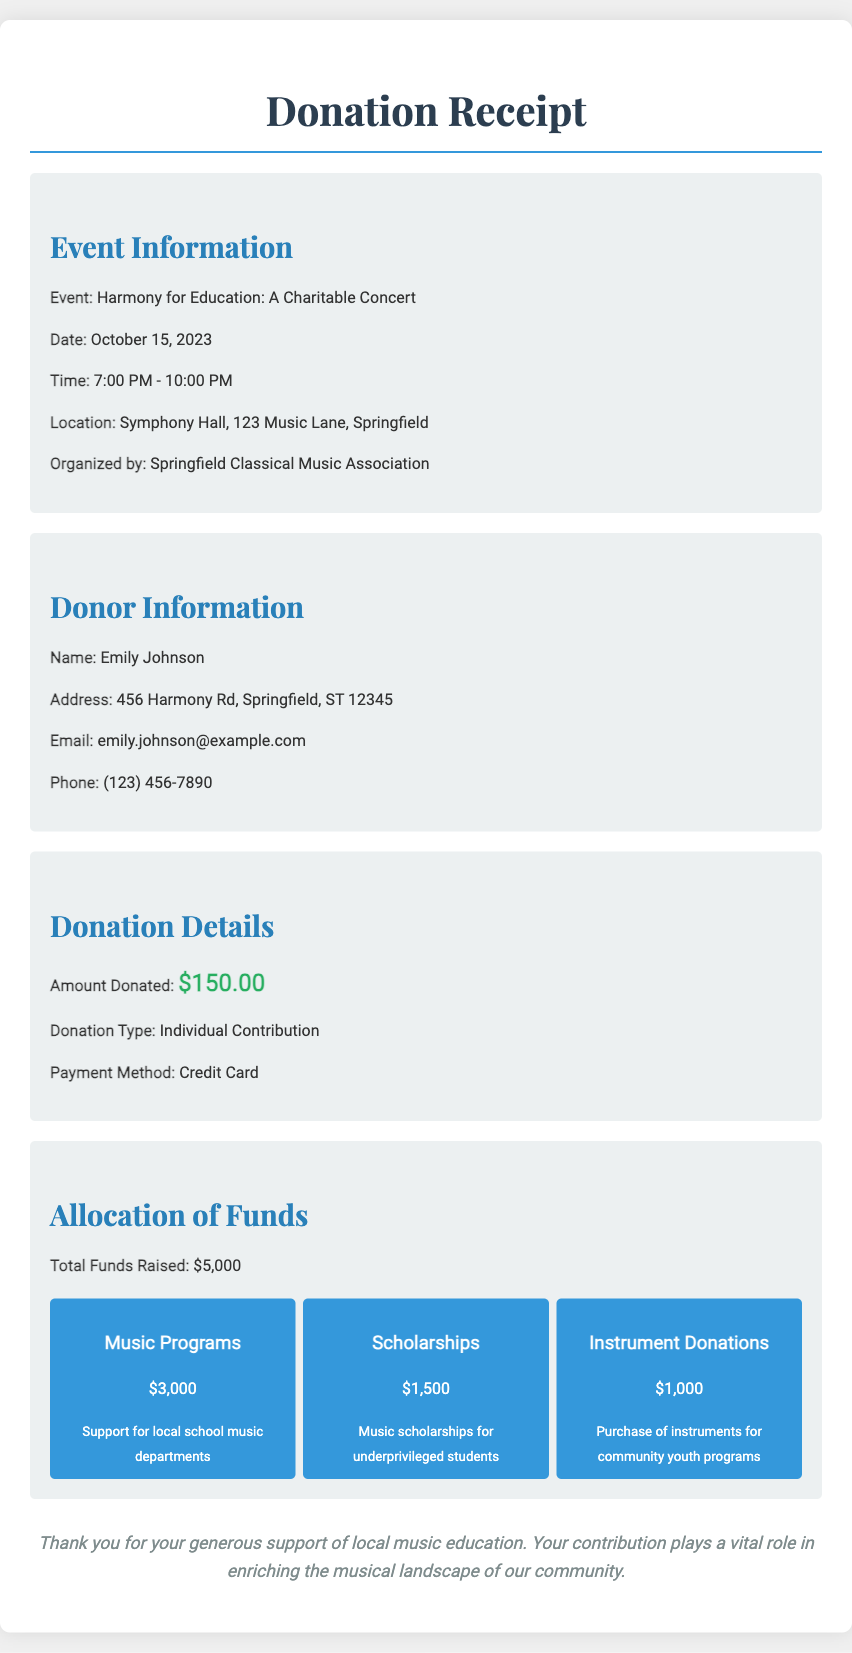What is the event name? The event name is mentioned in the document as "Harmony for Education: A Charitable Concert".
Answer: Harmony for Education: A Charitable Concert Who is the donor? The donor's name is listed in the document.
Answer: Emily Johnson What is the donation amount? The amount donated by the donor is specified in the donation details section.
Answer: $150.00 What is the total amount raised from the concert? The total funds raised is presented in the allocation section.
Answer: $5,000 How much money is allocated for music programs? The document specifies the amount allocated specifically for music programs in the allocation chart.
Answer: $3,000 What is the date of the event? The date of the event is clearly stated in the event information section.
Answer: October 15, 2023 What percentage of the total funds is allocated to scholarships? The document requires calculating the percentage based on the total funds and the amount for scholarships. Calculating $1,500 from $5,000 gives 30%.
Answer: 30% What is the purpose of the donation? The purpose of the donation is implied through the focus on local music education programs.
Answer: Support for local music education Which organization organized the event? The organizing entity for the charitable concert is mentioned in the event details section.
Answer: Springfield Classical Music Association 